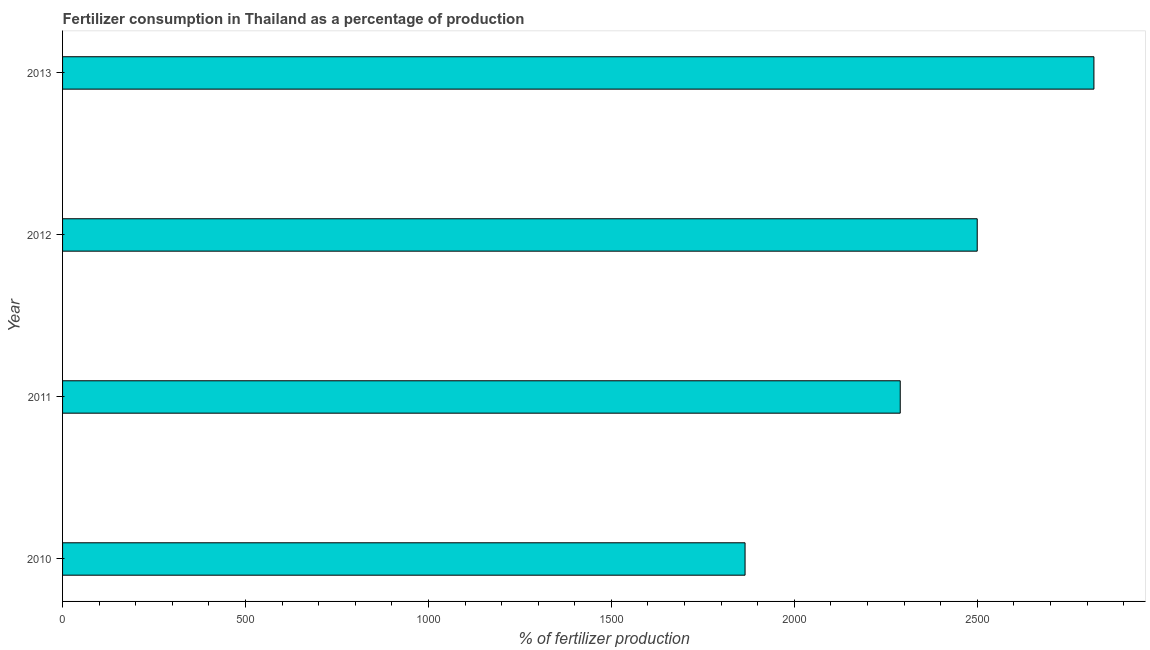Does the graph contain any zero values?
Keep it short and to the point. No. What is the title of the graph?
Provide a short and direct response. Fertilizer consumption in Thailand as a percentage of production. What is the label or title of the X-axis?
Your response must be concise. % of fertilizer production. What is the label or title of the Y-axis?
Offer a terse response. Year. What is the amount of fertilizer consumption in 2012?
Provide a short and direct response. 2499.92. Across all years, what is the maximum amount of fertilizer consumption?
Your answer should be compact. 2818.9. Across all years, what is the minimum amount of fertilizer consumption?
Offer a terse response. 1865.38. In which year was the amount of fertilizer consumption minimum?
Provide a succinct answer. 2010. What is the sum of the amount of fertilizer consumption?
Your response must be concise. 9473.7. What is the difference between the amount of fertilizer consumption in 2012 and 2013?
Your answer should be compact. -318.98. What is the average amount of fertilizer consumption per year?
Your answer should be compact. 2368.42. What is the median amount of fertilizer consumption?
Provide a succinct answer. 2394.71. What is the ratio of the amount of fertilizer consumption in 2011 to that in 2012?
Provide a short and direct response. 0.92. What is the difference between the highest and the second highest amount of fertilizer consumption?
Keep it short and to the point. 318.98. Is the sum of the amount of fertilizer consumption in 2011 and 2013 greater than the maximum amount of fertilizer consumption across all years?
Your answer should be very brief. Yes. What is the difference between the highest and the lowest amount of fertilizer consumption?
Provide a succinct answer. 953.52. How many bars are there?
Keep it short and to the point. 4. Are all the bars in the graph horizontal?
Keep it short and to the point. Yes. What is the difference between two consecutive major ticks on the X-axis?
Your answer should be very brief. 500. What is the % of fertilizer production of 2010?
Give a very brief answer. 1865.38. What is the % of fertilizer production of 2011?
Provide a succinct answer. 2289.49. What is the % of fertilizer production in 2012?
Your answer should be very brief. 2499.92. What is the % of fertilizer production in 2013?
Make the answer very short. 2818.9. What is the difference between the % of fertilizer production in 2010 and 2011?
Keep it short and to the point. -424.11. What is the difference between the % of fertilizer production in 2010 and 2012?
Your answer should be compact. -634.54. What is the difference between the % of fertilizer production in 2010 and 2013?
Make the answer very short. -953.52. What is the difference between the % of fertilizer production in 2011 and 2012?
Your response must be concise. -210.43. What is the difference between the % of fertilizer production in 2011 and 2013?
Keep it short and to the point. -529.4. What is the difference between the % of fertilizer production in 2012 and 2013?
Give a very brief answer. -318.98. What is the ratio of the % of fertilizer production in 2010 to that in 2011?
Your answer should be very brief. 0.81. What is the ratio of the % of fertilizer production in 2010 to that in 2012?
Your response must be concise. 0.75. What is the ratio of the % of fertilizer production in 2010 to that in 2013?
Ensure brevity in your answer.  0.66. What is the ratio of the % of fertilizer production in 2011 to that in 2012?
Offer a terse response. 0.92. What is the ratio of the % of fertilizer production in 2011 to that in 2013?
Make the answer very short. 0.81. What is the ratio of the % of fertilizer production in 2012 to that in 2013?
Your response must be concise. 0.89. 